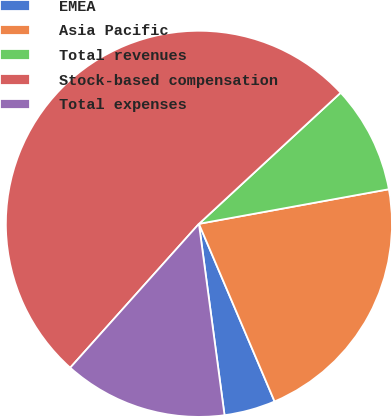Convert chart to OTSL. <chart><loc_0><loc_0><loc_500><loc_500><pie_chart><fcel>EMEA<fcel>Asia Pacific<fcel>Total revenues<fcel>Stock-based compensation<fcel>Total expenses<nl><fcel>4.29%<fcel>21.46%<fcel>9.01%<fcel>51.5%<fcel>13.73%<nl></chart> 